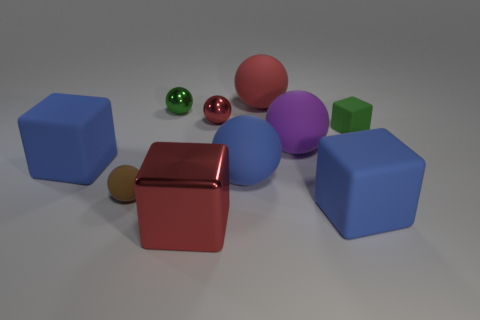There is a shiny thing to the left of the big red block; does it have the same shape as the small thing in front of the big blue rubber ball?
Give a very brief answer. Yes. How many balls have the same color as the large metallic cube?
Make the answer very short. 2. There is a tiny matte object that is the same shape as the large purple object; what color is it?
Keep it short and to the point. Brown. There is a metal thing that is in front of the small rubber cube; what number of green balls are on the right side of it?
Provide a short and direct response. 0. How many cylinders are big purple matte things or big red objects?
Give a very brief answer. 0. Are any gray matte cylinders visible?
Your answer should be very brief. No. There is a green thing that is the same shape as the red rubber thing; what size is it?
Keep it short and to the point. Small. What shape is the large red object behind the red metal object in front of the green rubber cube?
Ensure brevity in your answer.  Sphere. How many purple things are small cubes or large spheres?
Provide a short and direct response. 1. The small cube is what color?
Offer a terse response. Green. 